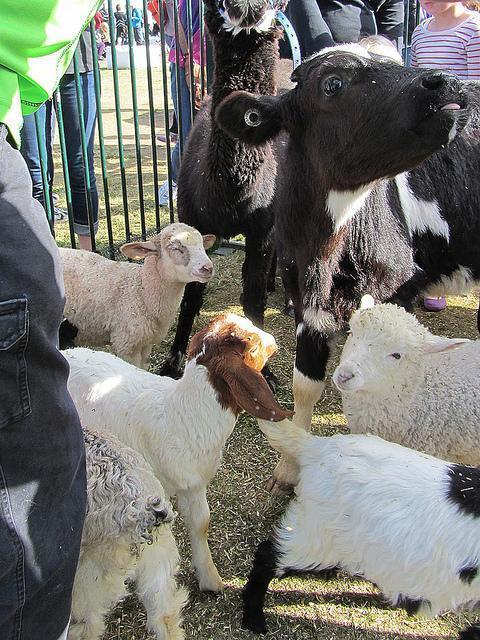What does the girl come to this venue for?
From the following set of four choices, select the accurate answer to respond to the question.
Options: Raising animals, feeding animals, petting animals, riding animals. Petting animals. 